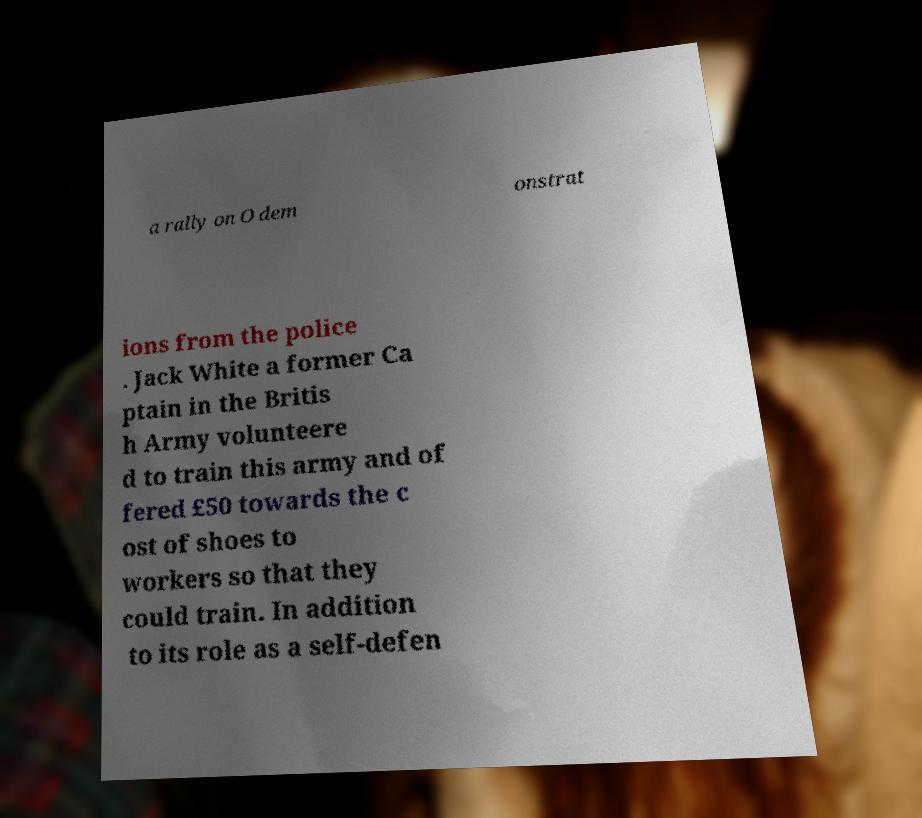Please read and relay the text visible in this image. What does it say? a rally on O dem onstrat ions from the police . Jack White a former Ca ptain in the Britis h Army volunteere d to train this army and of fered £50 towards the c ost of shoes to workers so that they could train. In addition to its role as a self-defen 